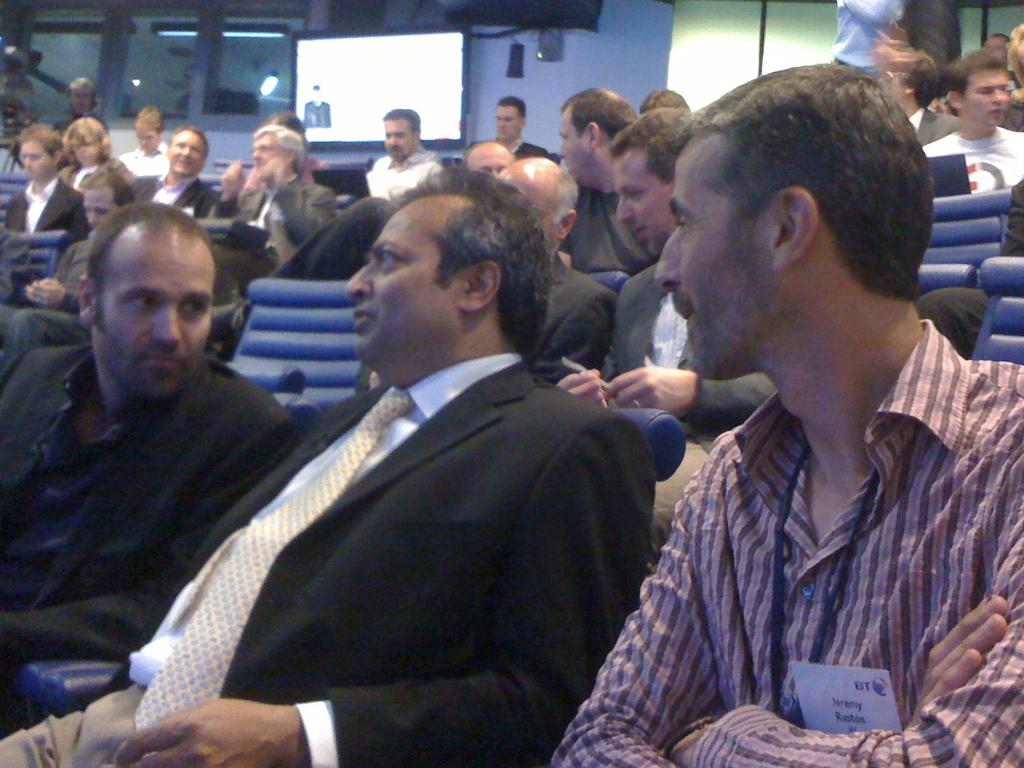What are the men in the image wearing? The men in the image are wearing suits. What are the men doing in the image? The men are sitting on chairs in the image. What can be seen on the wall in the background of the image? There are windows on the wall in the background of the image. What is located in the middle of the windows? There is a screen in the middle of the windows. What type of zinc is present on the shelf in the image? There is no zinc or shelf present in the image. How many boards can be seen on the wall in the image? There are no boards visible in the image; only windows and a screen are present on the wall. 